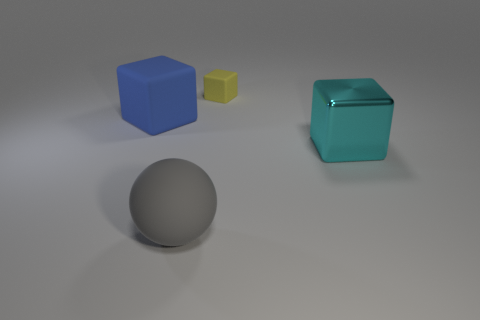There is a large object that is in front of the big blue matte block and to the left of the small yellow block; what color is it?
Offer a very short reply. Gray. The ball has what color?
Your answer should be very brief. Gray. Is the gray sphere made of the same material as the cube that is behind the big rubber block?
Provide a succinct answer. Yes. What is the shape of the tiny yellow object that is the same material as the large blue block?
Provide a short and direct response. Cube. There is another matte thing that is the same size as the blue matte thing; what color is it?
Ensure brevity in your answer.  Gray. There is a object that is to the left of the matte sphere; is it the same size as the gray rubber sphere?
Make the answer very short. Yes. What number of cubes are there?
Provide a succinct answer. 3. How many blocks are big blue objects or yellow matte objects?
Your answer should be very brief. 2. What number of yellow cubes are on the left side of the rubber cube left of the yellow matte block?
Your answer should be very brief. 0. Do the yellow object and the large cyan object have the same material?
Keep it short and to the point. No. 